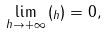<formula> <loc_0><loc_0><loc_500><loc_500>\lim _ { h \to + \infty } { ( _ { h } ) } = 0 ,</formula> 